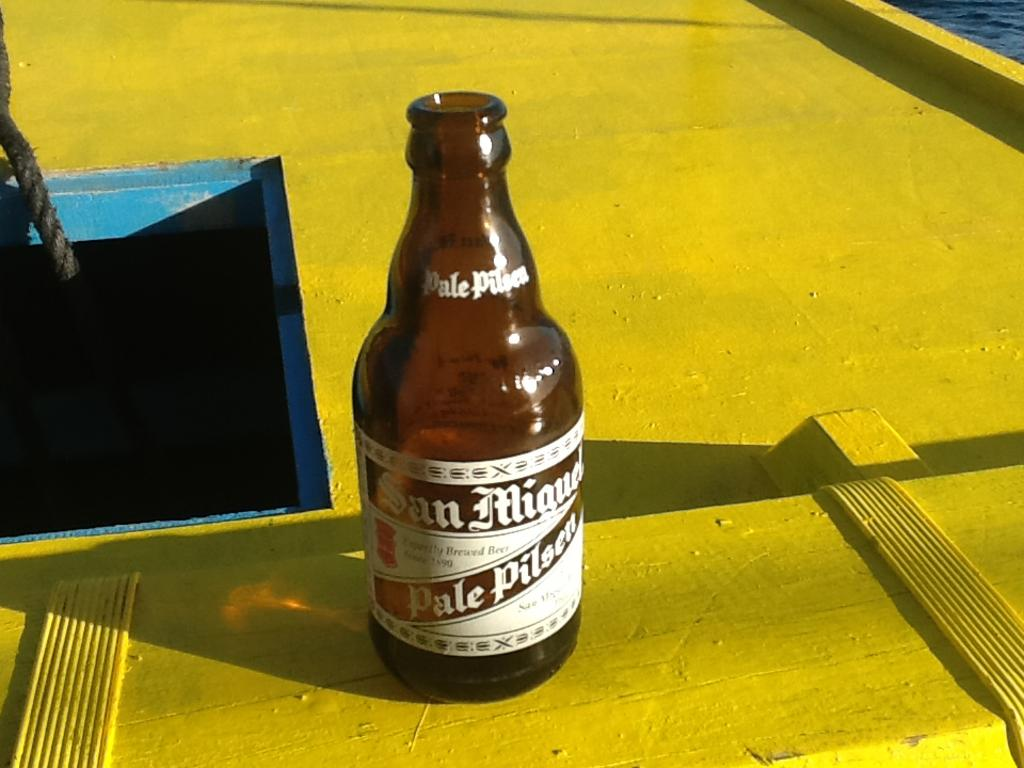<image>
Write a terse but informative summary of the picture. a brown glass bottle of san miguel pale pilsner 